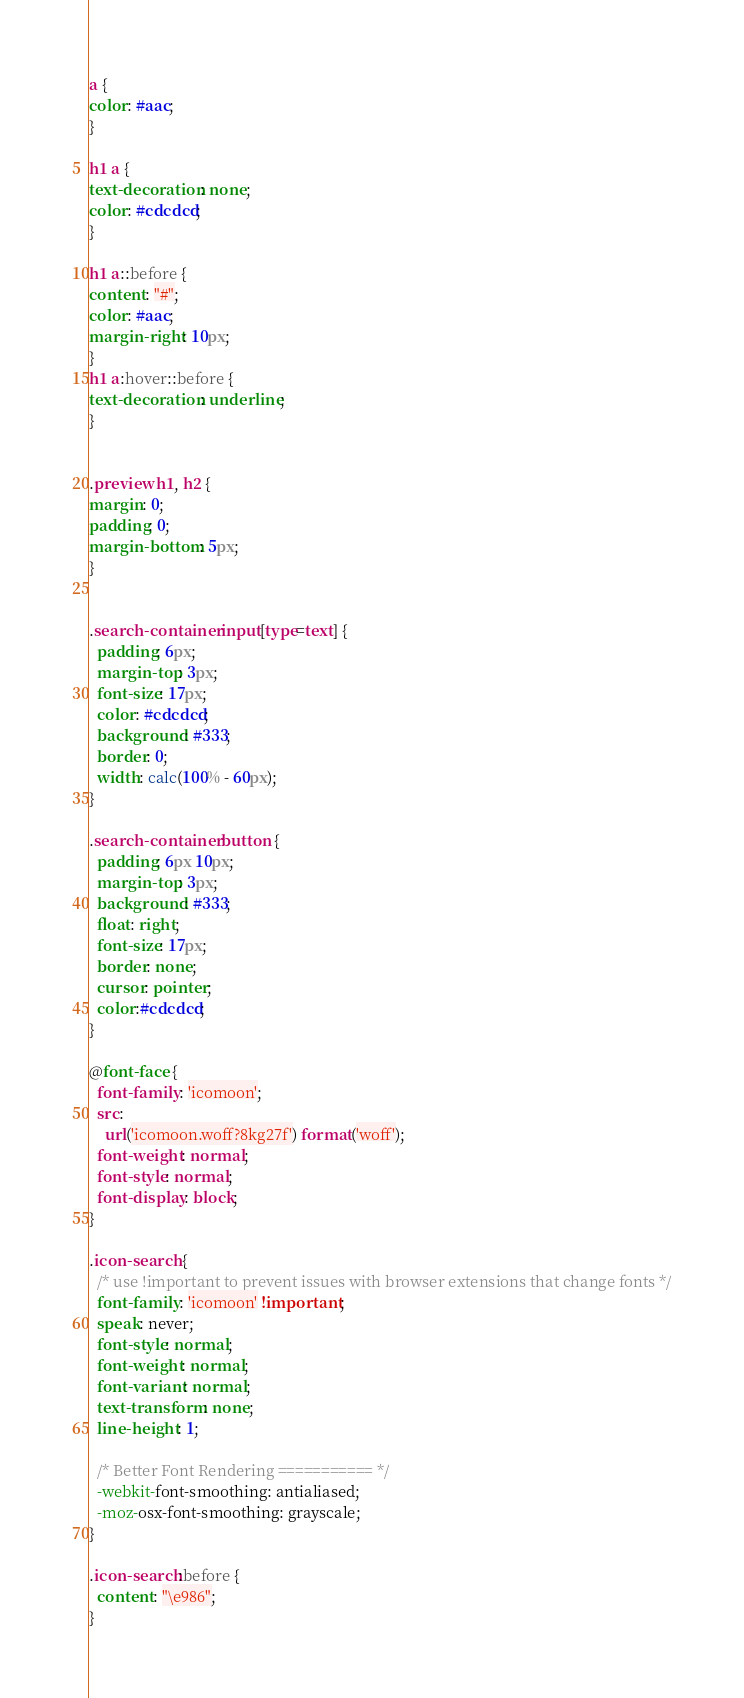Convert code to text. <code><loc_0><loc_0><loc_500><loc_500><_CSS_>a {
color: #aac;
}

h1 a {
text-decoration: none;
color: #cdcdcd;
}

h1 a::before {
content: "#";
color: #aac;
margin-right: 10px;
}
h1 a:hover::before {
text-decoration: underline;
}


.preview h1, h2 {
margin: 0;
padding: 0;
margin-bottom: 5px;
}


.search-container input[type=text] {
  padding: 6px;
  margin-top: 3px;
  font-size: 17px;
  color: #cdcdcd;
  background: #333;
  border: 0;
  width: calc(100% - 60px);
}

.search-container button {
  padding: 6px 10px;
  margin-top: 3px;
  background: #333;
  float: right;
  font-size: 17px;
  border: none;
  cursor: pointer;
  color:#cdcdcd;
}

@font-face {
  font-family: 'icomoon';
  src:  
    url('icomoon.woff?8kg27f') format('woff');
  font-weight: normal;
  font-style: normal;
  font-display: block;
}

.icon-search {
  /* use !important to prevent issues with browser extensions that change fonts */
  font-family: 'icomoon' !important;
  speak: never;
  font-style: normal;
  font-weight: normal;
  font-variant: normal;
  text-transform: none;
  line-height: 1;

  /* Better Font Rendering =========== */
  -webkit-font-smoothing: antialiased;
  -moz-osx-font-smoothing: grayscale;
}

.icon-search:before {
  content: "\e986";
}
</code> 